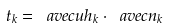<formula> <loc_0><loc_0><loc_500><loc_500>t _ { k } = \ a v e c u { h } _ { k } \cdot \ a v e c { n } _ { k }</formula> 